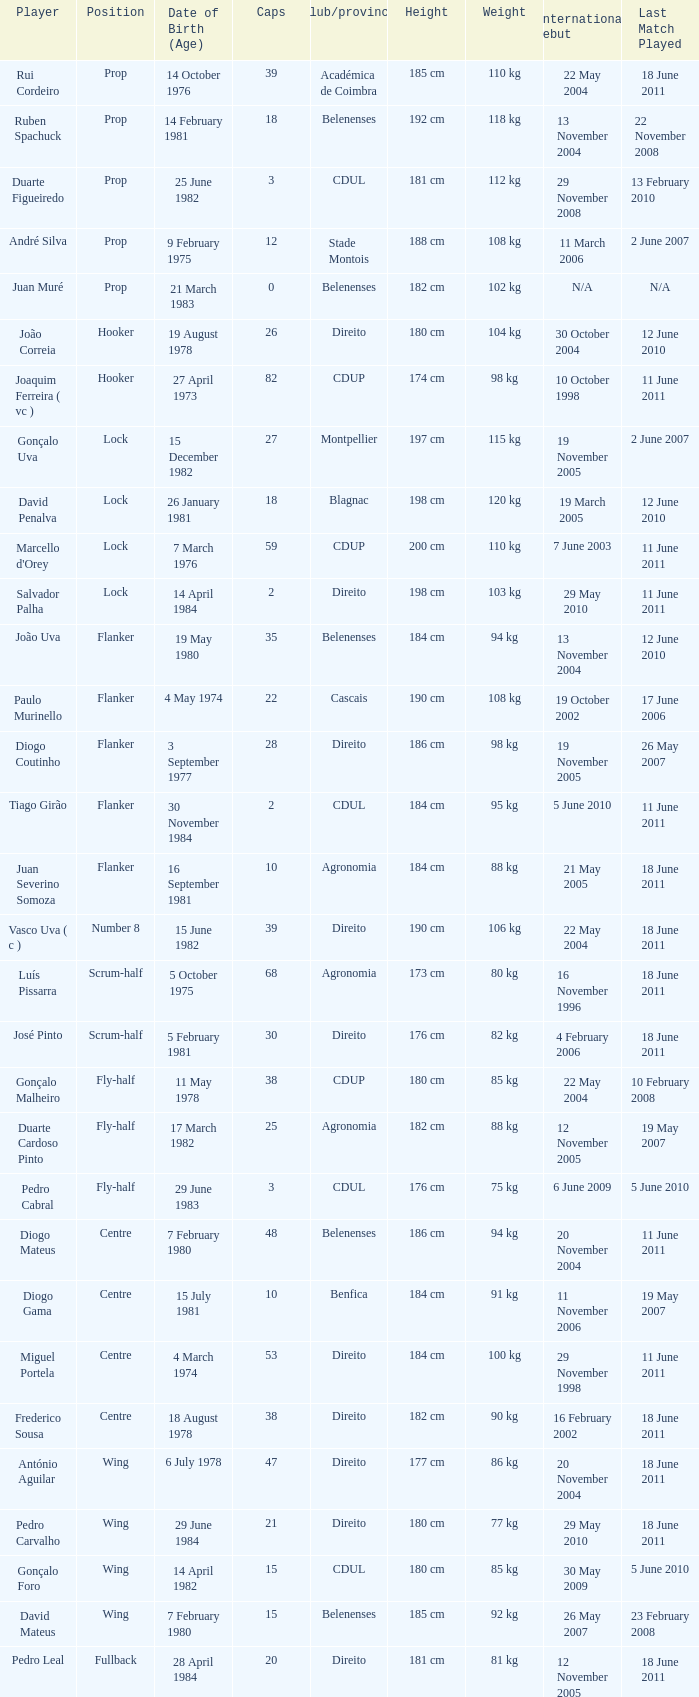Which player has a Club/province of direito, less than 21 caps, and a Position of lock? Salvador Palha. 